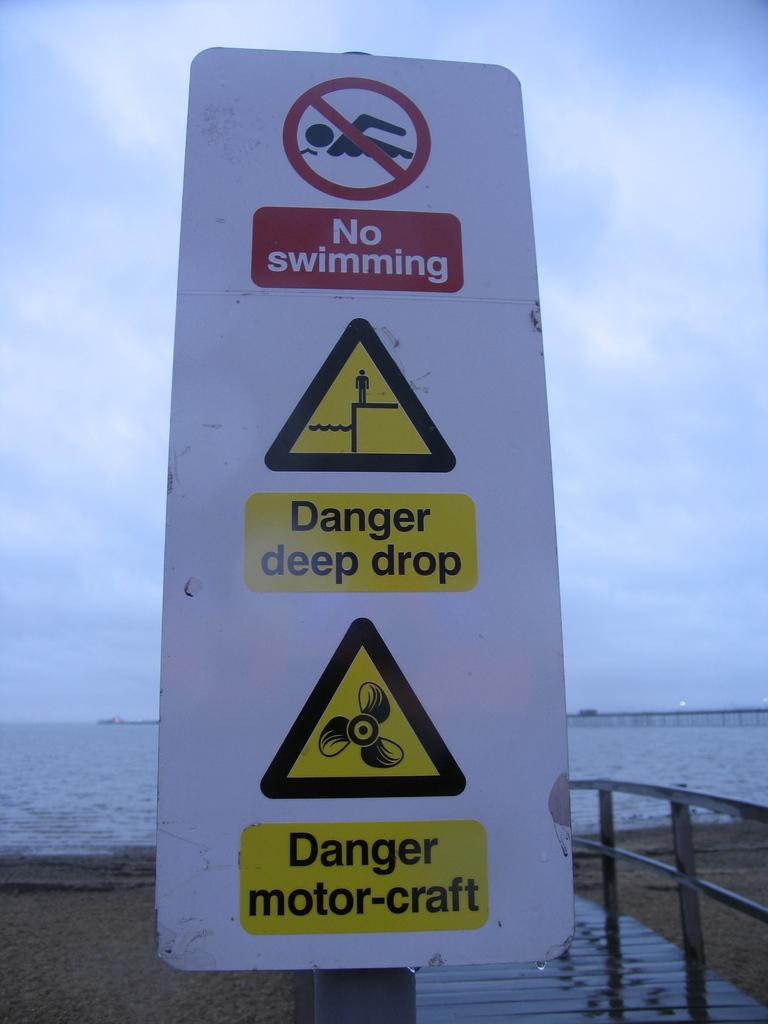<image>
Give a short and clear explanation of the subsequent image. Several warning signs, including one for "no swimming" and "danger deep drop" are posted. 